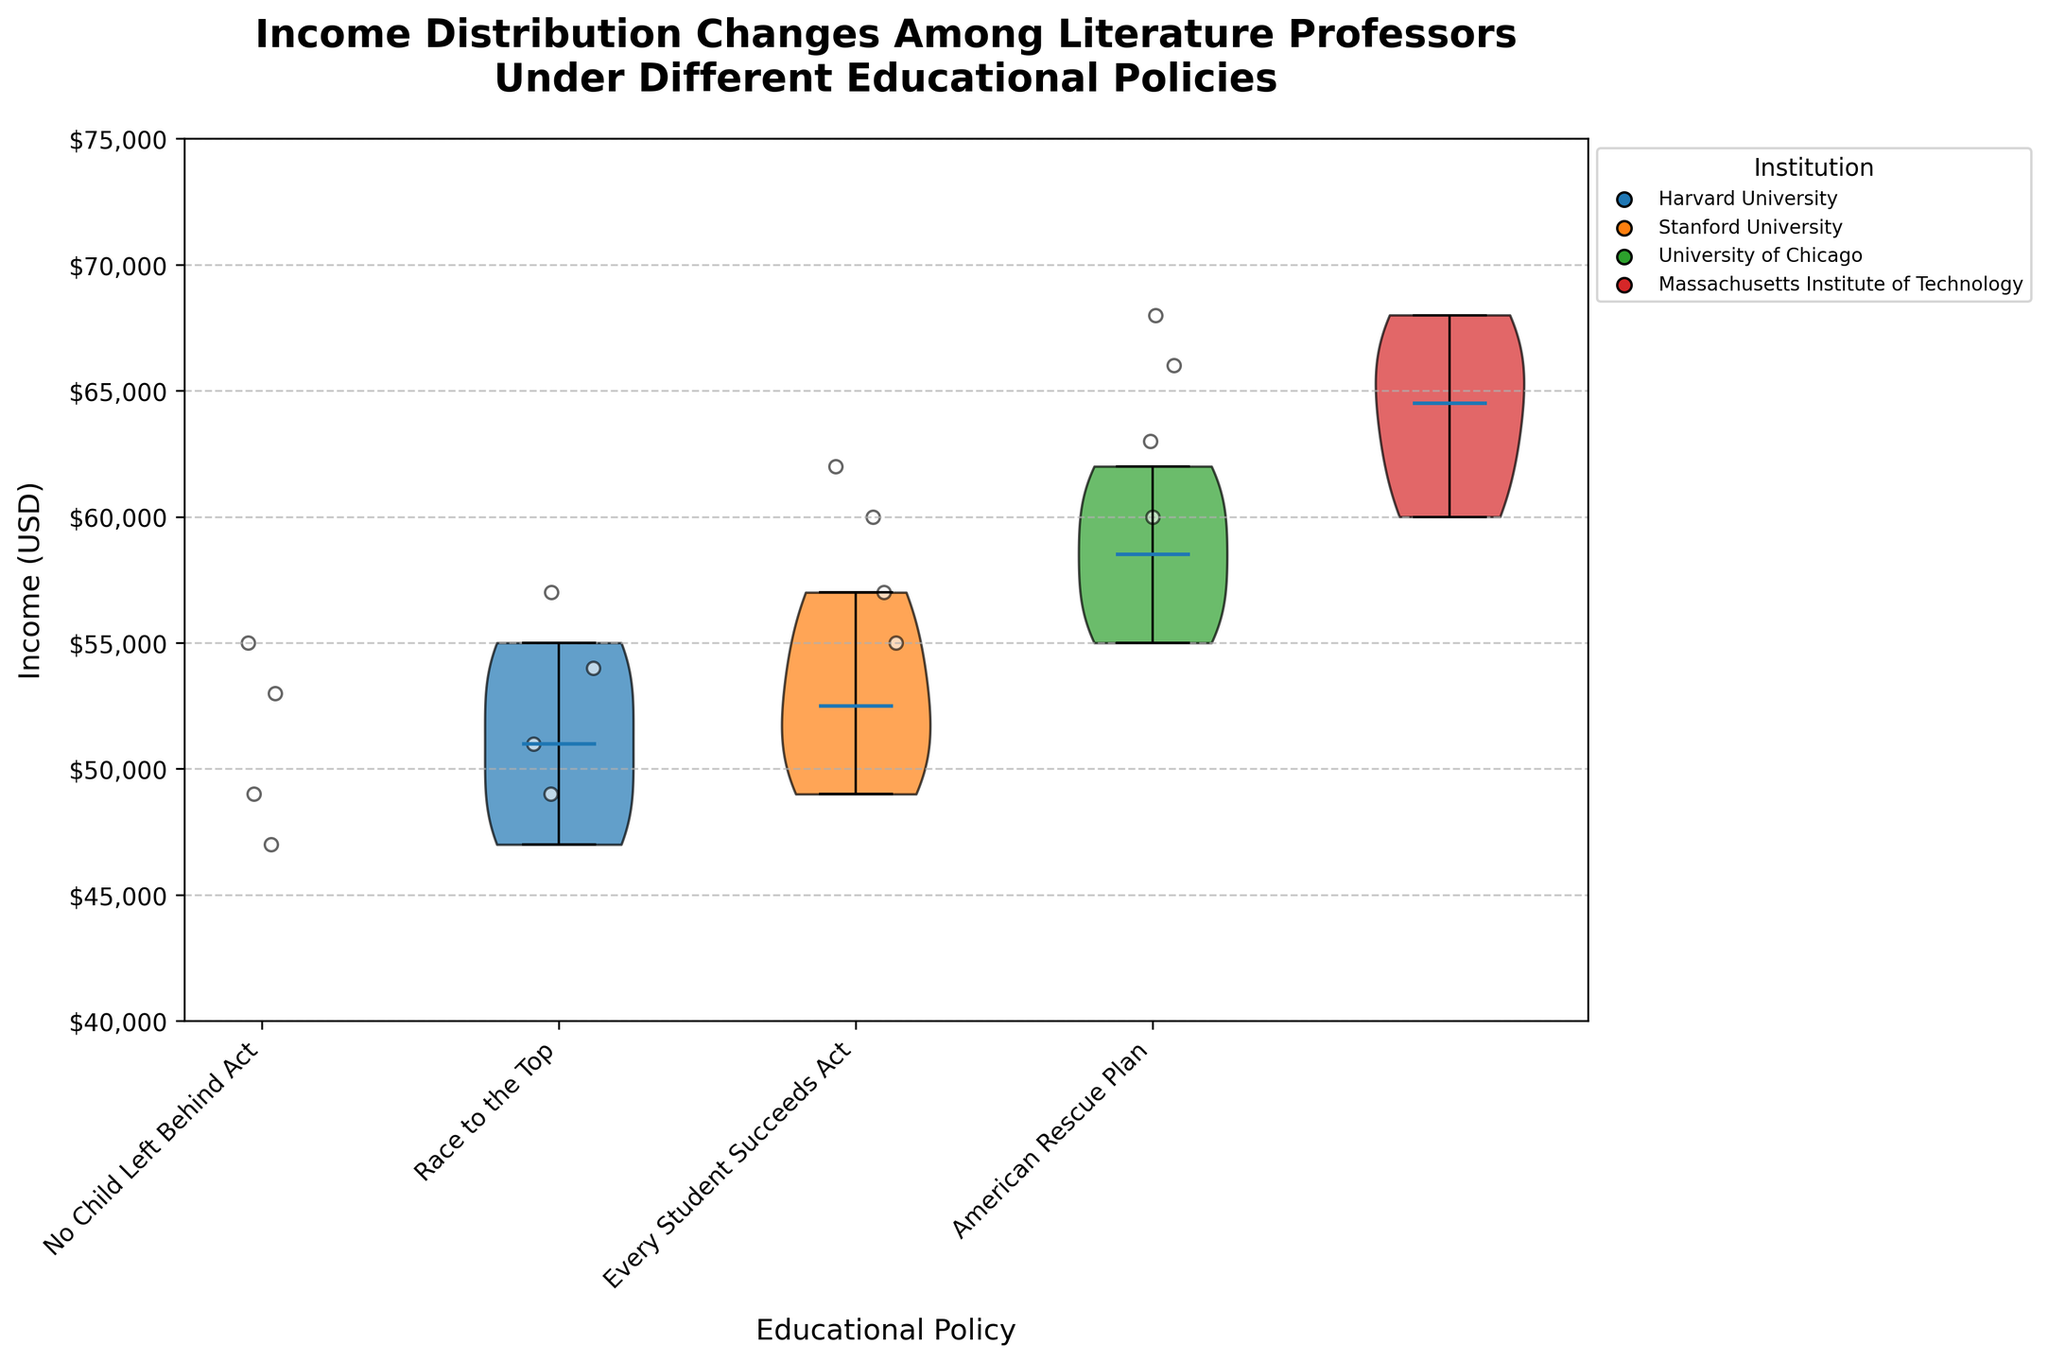What is the title of the violin chart? To determine the title, we look at the top of the chart where the title text is displayed. In this particular chart, it is clearly labeled and states the main focus of the visual representation.
Answer: Income Distribution Changes Among Literature Professors Under Different Educational Policies How many educational policies are represented in the chart? We can count the number of unique labels shown on the x-axis, as each label represents a different educational policy.
Answer: 4 Which educational policy shows the highest median income for literature professors? Looking at the middle line within each violin that indicates the median income, we compare the positions. The policy with the highest median is the one where this line is the highest.
Answer: American Rescue Plan What is the approximate range of incomes under the No Child Left Behind Act? By observing the extent of the violin shape for this policy, we look at the highest and lowest points of the distribution.
Answer: $47,000 to $55,000 How does the median income under the Race to the Top policy compare to the No Child Left Behind Act policy? We locate the median lines within both violins and compare their positions to see which is higher or lower.
Answer: Higher Which institutions are represented in the America Rescue Plan jittered points? We identify the colors associated with the jittered points under this policy and match them with the legend specifying each institution.
Answer: Harvard University, Stanford University, University of Chicago, Massachusetts Institute of Technology What is the average income for literature professors under the Every Student Succeeds Act policy? We add up the income values under this policy ($62,000 + $55,000 + $57,000 + $60,000) and then divide by the number of data points (4) to get the average.
Answer: $58,500 Between which two policies does the income distribution show the greatest increase in median income? By looking at the median lines across all violins, we compare increases from one policy to the next to find the largest difference.
Answer: Race to the Top to Every Student Succeeds Act Are the income distributions under different educational policies normally distributed or do they show some skewness? We observe the shape of the violins, considering whether they are symmetrical (indicating normal distribution) or show skewness by being wider or longer on one end.
Answer: Skewness How are the means of the income distributions displayed in the chart? This chart does not display means because it specifies showing medians only. By looking at how the statistical elements are represented in this chart, we confirm that only the medians are depicted.
Answer: Not shown 